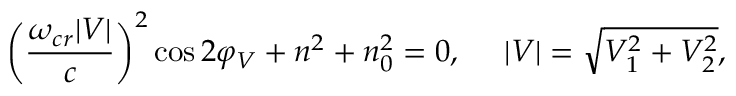<formula> <loc_0><loc_0><loc_500><loc_500>\left ( \frac { \omega _ { c r } | V | } { c } \right ) ^ { 2 } \cos { 2 \varphi _ { V } } + n ^ { 2 } + n _ { 0 } ^ { 2 } = 0 , \quad | V | = \sqrt { V _ { 1 } ^ { 2 } + V _ { 2 } ^ { 2 } } ,</formula> 